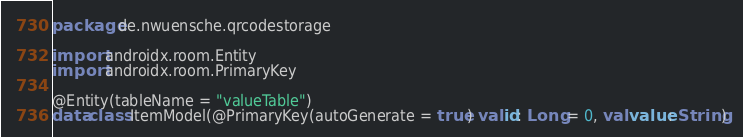<code> <loc_0><loc_0><loc_500><loc_500><_Kotlin_>package de.nwuensche.qrcodestorage

import androidx.room.Entity
import androidx.room.PrimaryKey

@Entity(tableName = "valueTable")
data class ItemModel(@PrimaryKey(autoGenerate = true) val id: Long = 0, val value: String)</code> 